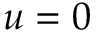<formula> <loc_0><loc_0><loc_500><loc_500>u = 0</formula> 